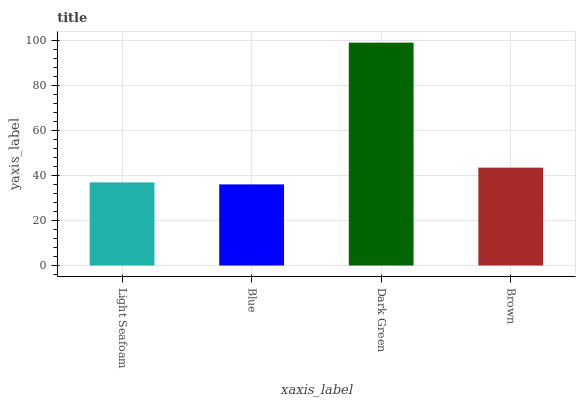Is Blue the minimum?
Answer yes or no. Yes. Is Dark Green the maximum?
Answer yes or no. Yes. Is Dark Green the minimum?
Answer yes or no. No. Is Blue the maximum?
Answer yes or no. No. Is Dark Green greater than Blue?
Answer yes or no. Yes. Is Blue less than Dark Green?
Answer yes or no. Yes. Is Blue greater than Dark Green?
Answer yes or no. No. Is Dark Green less than Blue?
Answer yes or no. No. Is Brown the high median?
Answer yes or no. Yes. Is Light Seafoam the low median?
Answer yes or no. Yes. Is Blue the high median?
Answer yes or no. No. Is Brown the low median?
Answer yes or no. No. 